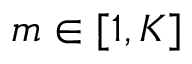Convert formula to latex. <formula><loc_0><loc_0><loc_500><loc_500>m \in [ 1 , K ]</formula> 